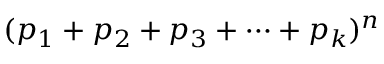Convert formula to latex. <formula><loc_0><loc_0><loc_500><loc_500>( p _ { 1 } + p _ { 2 } + p _ { 3 } + \cdots + p _ { k } ) ^ { n }</formula> 